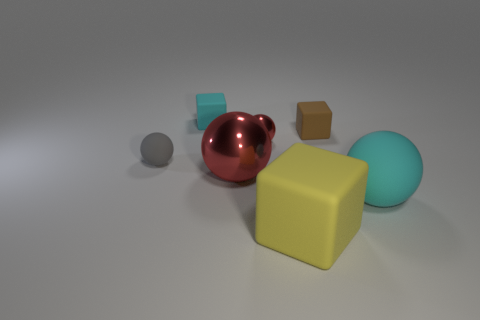Add 3 tiny red balls. How many objects exist? 10 Subtract all yellow blocks. How many blocks are left? 2 Subtract all gray balls. How many balls are left? 3 Subtract all gray cubes. How many red spheres are left? 2 Add 1 cyan blocks. How many cyan blocks exist? 2 Subtract 1 brown cubes. How many objects are left? 6 Subtract all cubes. How many objects are left? 4 Subtract 1 spheres. How many spheres are left? 3 Subtract all gray cubes. Subtract all green balls. How many cubes are left? 3 Subtract all tiny spheres. Subtract all large blue rubber things. How many objects are left? 5 